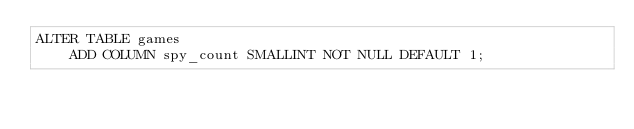<code> <loc_0><loc_0><loc_500><loc_500><_SQL_>ALTER TABLE games
    ADD COLUMN spy_count SMALLINT NOT NULL DEFAULT 1;</code> 